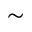<formula> <loc_0><loc_0><loc_500><loc_500>\sim</formula> 